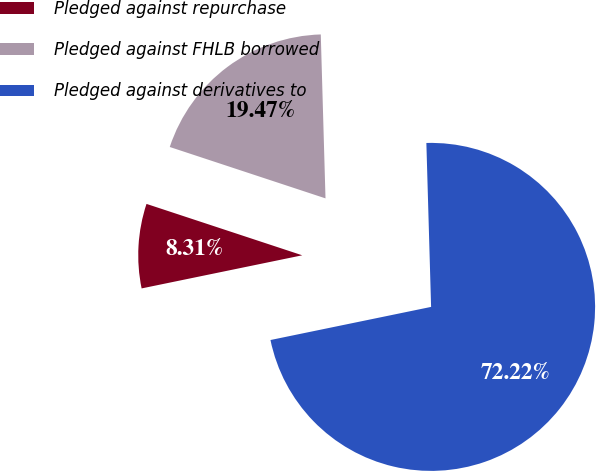Convert chart. <chart><loc_0><loc_0><loc_500><loc_500><pie_chart><fcel>Pledged against repurchase<fcel>Pledged against FHLB borrowed<fcel>Pledged against derivatives to<nl><fcel>8.31%<fcel>19.47%<fcel>72.23%<nl></chart> 